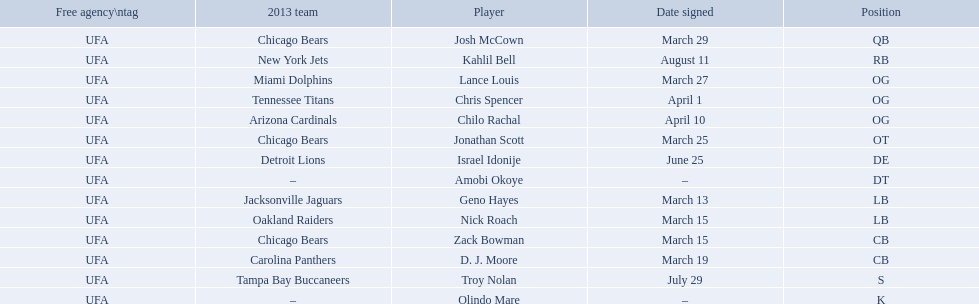What are all the dates signed? March 29, August 11, March 27, April 1, April 10, March 25, June 25, March 13, March 15, March 15, March 19, July 29. Which of these are duplicates? March 15, March 15. Who has the same one as nick roach? Zack Bowman. 